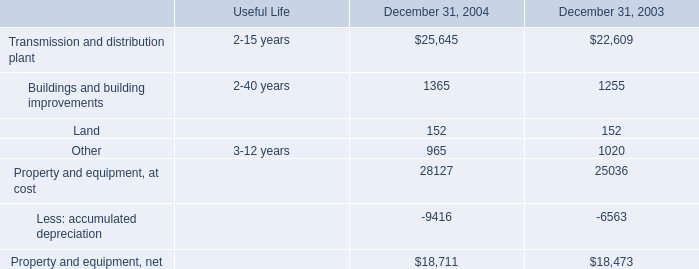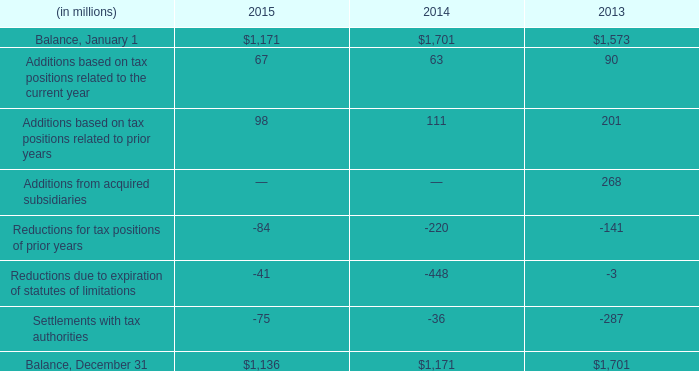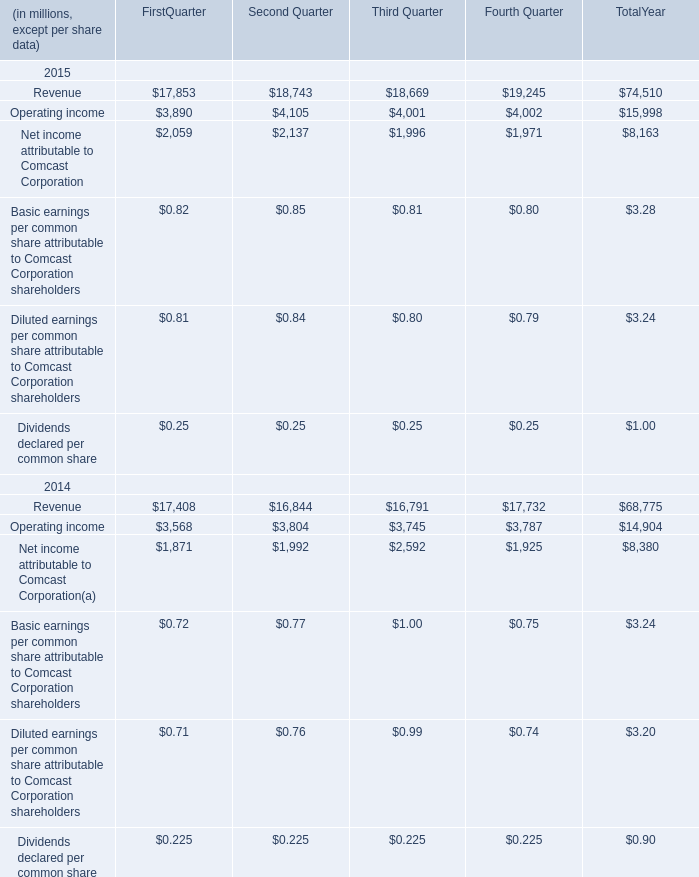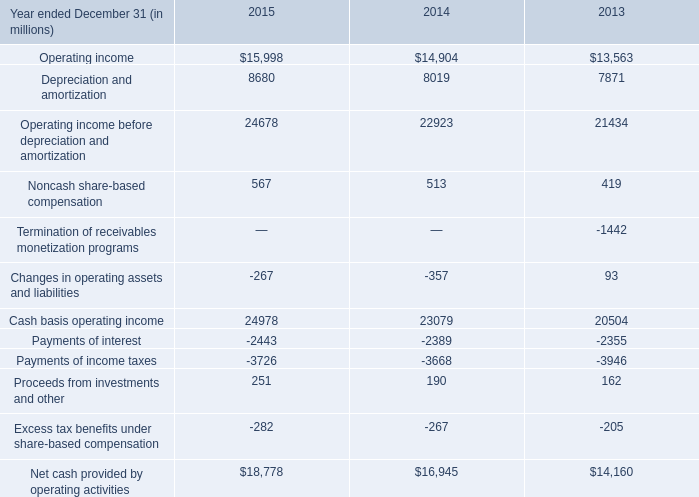What is the sum of Depreciation and amortization in 2014 and Buildings and building improvements in 2004? (in million) 
Computations: (8019 + 1365)
Answer: 9384.0. 